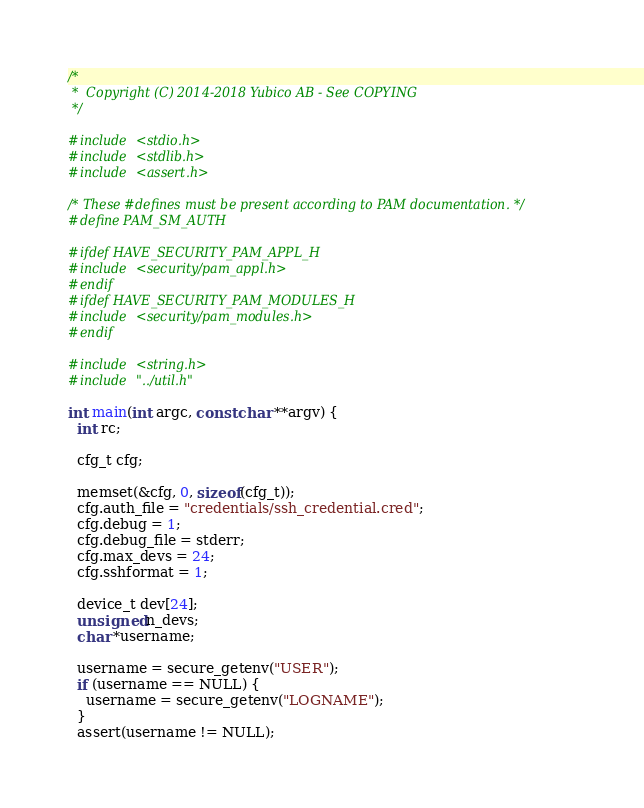Convert code to text. <code><loc_0><loc_0><loc_500><loc_500><_C_>/*
 *  Copyright (C) 2014-2018 Yubico AB - See COPYING
 */

#include <stdio.h>
#include <stdlib.h>
#include <assert.h>

/* These #defines must be present according to PAM documentation. */
#define PAM_SM_AUTH

#ifdef HAVE_SECURITY_PAM_APPL_H
#include <security/pam_appl.h>
#endif
#ifdef HAVE_SECURITY_PAM_MODULES_H
#include <security/pam_modules.h>
#endif

#include <string.h>
#include "../util.h"

int main(int argc, const char **argv) {
  int rc;

  cfg_t cfg;

  memset(&cfg, 0, sizeof(cfg_t));
  cfg.auth_file = "credentials/ssh_credential.cred";
  cfg.debug = 1;
  cfg.debug_file = stderr;
  cfg.max_devs = 24;
  cfg.sshformat = 1;

  device_t dev[24];
  unsigned n_devs;
  char *username;

  username = secure_getenv("USER");
  if (username == NULL) {
    username = secure_getenv("LOGNAME");
  }
  assert(username != NULL);
</code> 